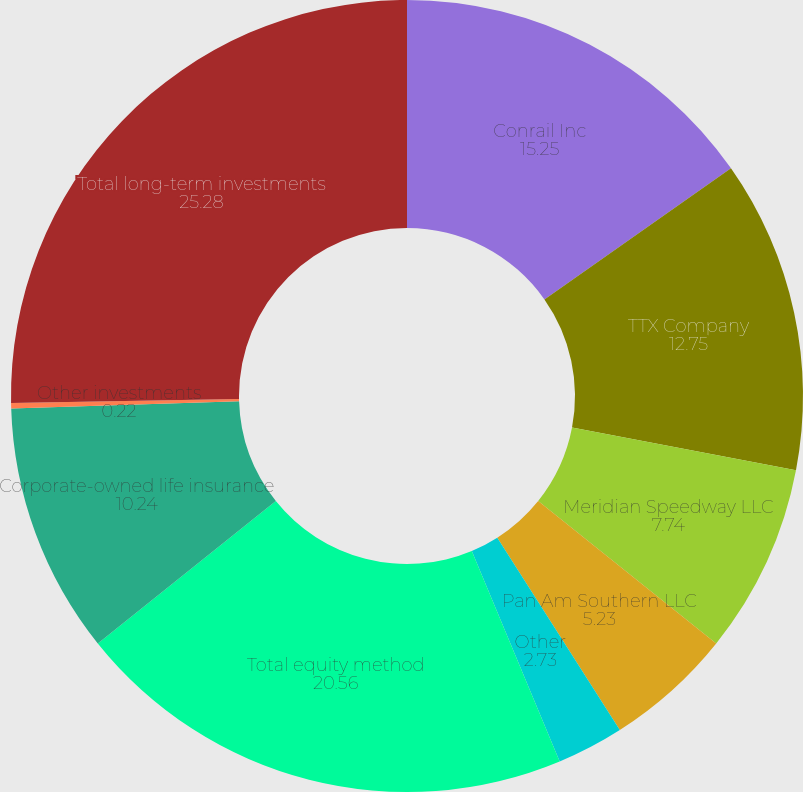Convert chart to OTSL. <chart><loc_0><loc_0><loc_500><loc_500><pie_chart><fcel>Conrail Inc<fcel>TTX Company<fcel>Meridian Speedway LLC<fcel>Pan Am Southern LLC<fcel>Other<fcel>Total equity method<fcel>Corporate-owned life insurance<fcel>Other investments<fcel>Total long-term investments<nl><fcel>15.25%<fcel>12.75%<fcel>7.74%<fcel>5.23%<fcel>2.73%<fcel>20.56%<fcel>10.24%<fcel>0.22%<fcel>25.28%<nl></chart> 